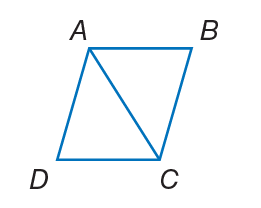Answer the mathemtical geometry problem and directly provide the correct option letter.
Question: Quadrilateral A B C D is a rhombus. If m \angle B C D = 64, find m \angle B A C.
Choices: A: 32 B: 39 C: 64 D: 67 A 